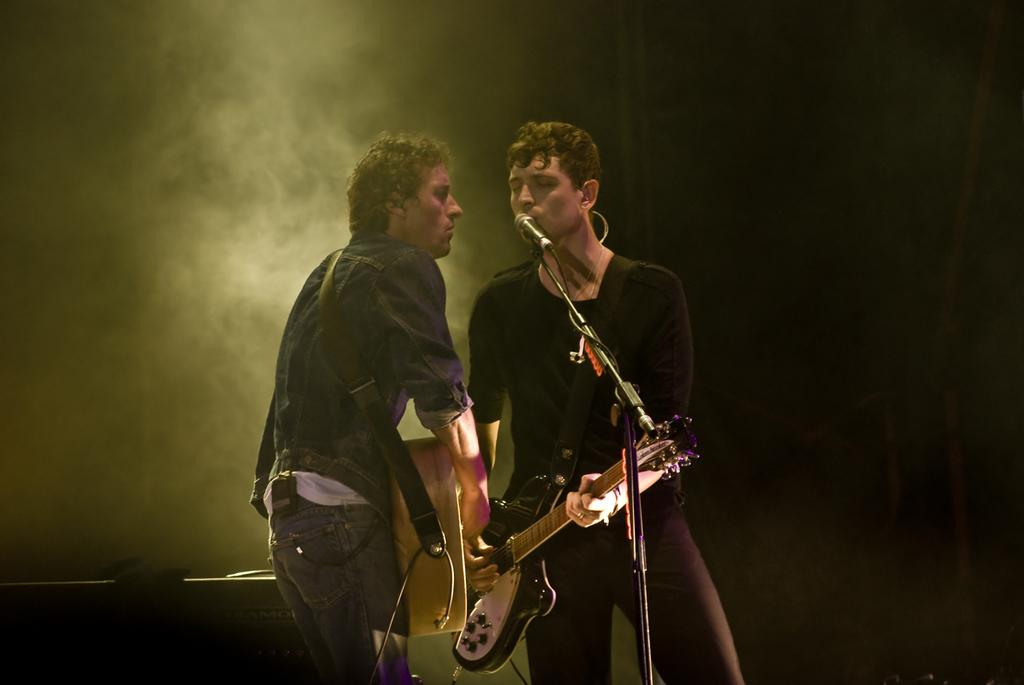How many people are in the image? There are two persons in the image. What are the two persons doing in the image? The two persons are singing and playing guitars. What objects are the two persons holding in the image? The two persons are holding microphones in the image. What type of poison is being used by the two persons in the image? There is no poison present in the image; the two persons are singing and playing guitars. What type of sheet is covering the guitars in the image? There is no sheet covering the guitars in the image; the guitars are visible and being played by the two persons. 